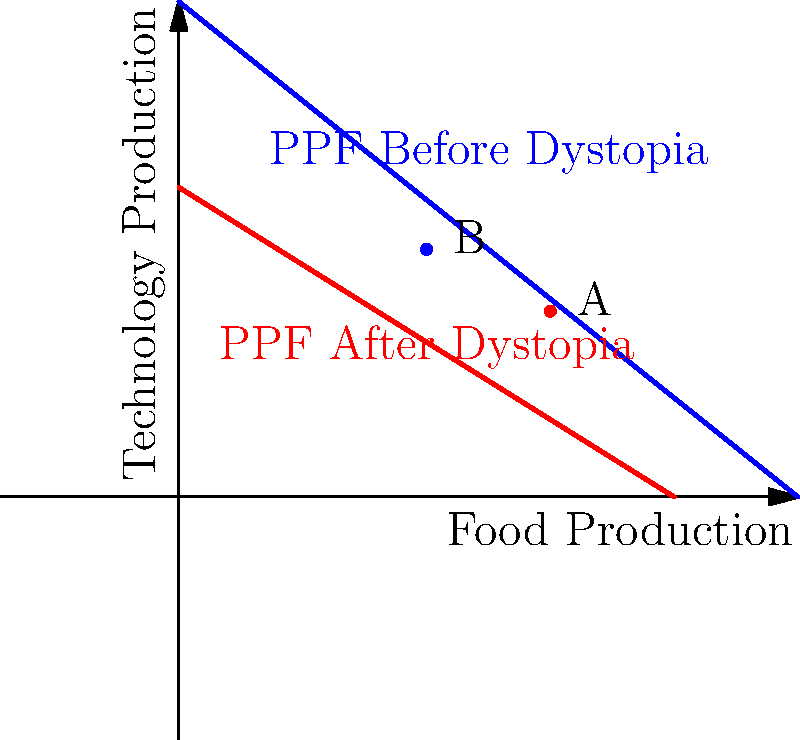In a fictional dystopian society, resources have been reallocated due to authoritarian control. The production possibilities frontier (PPF) for food and technology has shifted as shown in the graph. Point A represents the current production point in the dystopian society, while point B represents a potential production point if resources were allocated differently. Using economic analysis, explain the impact of this dystopian regime on the society's productive capacity and efficiency. How might this scenario be incorporated into a compelling narrative about economic choices in a repressive system? To analyze this scenario, let's break it down step-by-step:

1. PPF Shift: The graph shows two PPFs - the blue curve represents the society before the dystopia, and the red curve represents the society after the dystopian regime took control. The inward shift of the PPF indicates a decrease in overall productive capacity.

2. Reasons for PPF Shift: This could be due to:
   a) Destruction or misallocation of resources
   b) Loss of skilled labor (e.g., through persecution or emigration)
   c) Technological regression or lack of innovation

3. Current Production (Point A):
   - Located on the new PPF, indicating production is efficient given the new constraints
   - However, it produces less of both goods compared to what was possible before

4. Potential Production (Point B):
   - Located inside the original PPF but outside the new one
   - Represents a combination that is no longer attainable under the new regime

5. Efficiency vs. Capacity:
   - The society is producing efficiently on its new PPF (at point A)
   - But its overall capacity has decreased significantly

6. Opportunity Cost:
   - The slope of the PPF represents the opportunity cost of producing one good in terms of the other
   - The steeper curve of the new PPF suggests higher opportunity costs, indicating less flexibility in production

7. Economic Impact:
   - Reduced overall output and standard of living
   - Possible shortages in both food and technology
   - Limited economic choices and flexibility

8. Narrative Potential:
   - This scenario could be woven into a story about:
     a) The human cost of authoritarian control
     b) The struggle for resources in a constrained economy
     c) The tension between efficiency and freedom
     d) Characters adapting to new economic realities or fighting to restore former productivity

By combining economic analysis with storytelling, this scenario provides a rich backdrop for exploring themes of scarcity, choice, and the impact of political systems on economic outcomes.
Answer: The dystopian regime has reduced overall productive capacity, as shown by the inward shift of the PPF, while maintaining productive efficiency at a lower level. This results in decreased output, higher opportunity costs, and limited economic choices, providing a compelling basis for a narrative about scarcity and adaptation in a repressive system. 